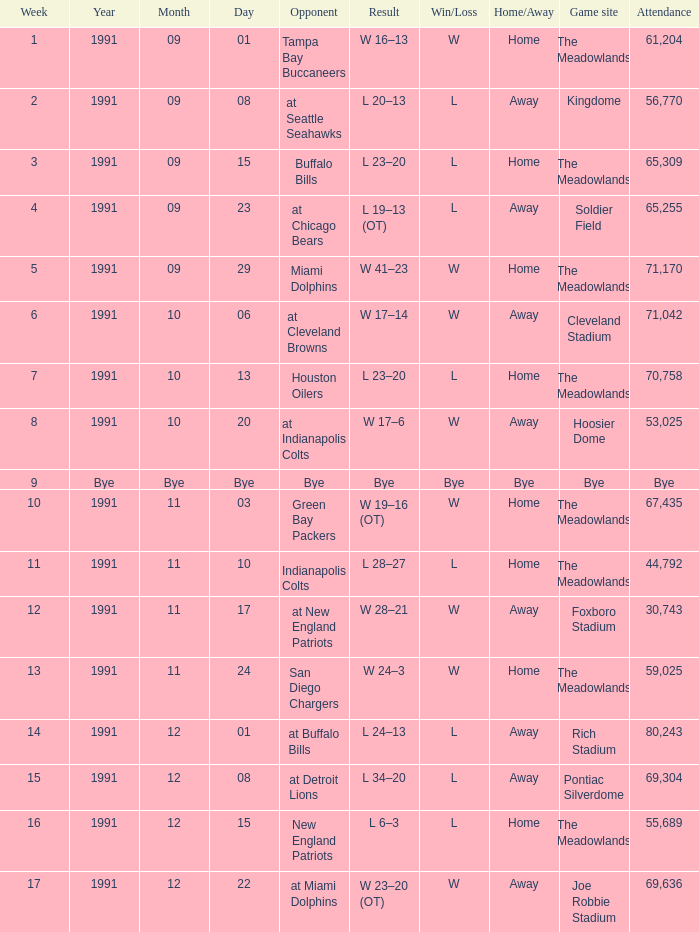What was the Attendance in Week 17? 69636.0. 